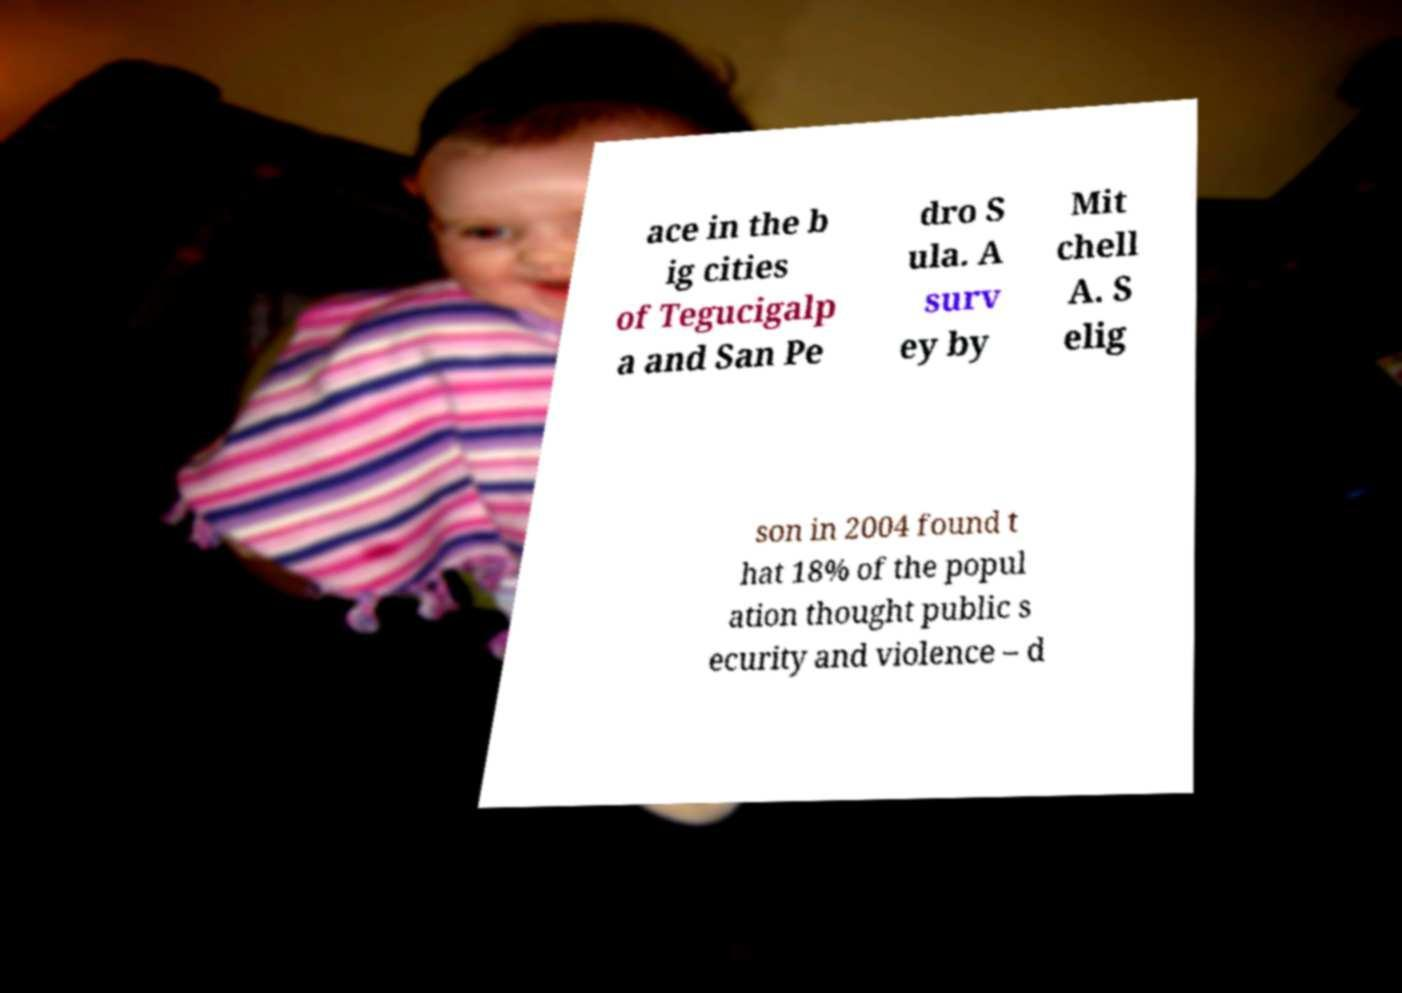Please read and relay the text visible in this image. What does it say? ace in the b ig cities of Tegucigalp a and San Pe dro S ula. A surv ey by Mit chell A. S elig son in 2004 found t hat 18% of the popul ation thought public s ecurity and violence – d 